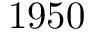<formula> <loc_0><loc_0><loc_500><loc_500>1 9 5 0</formula> 